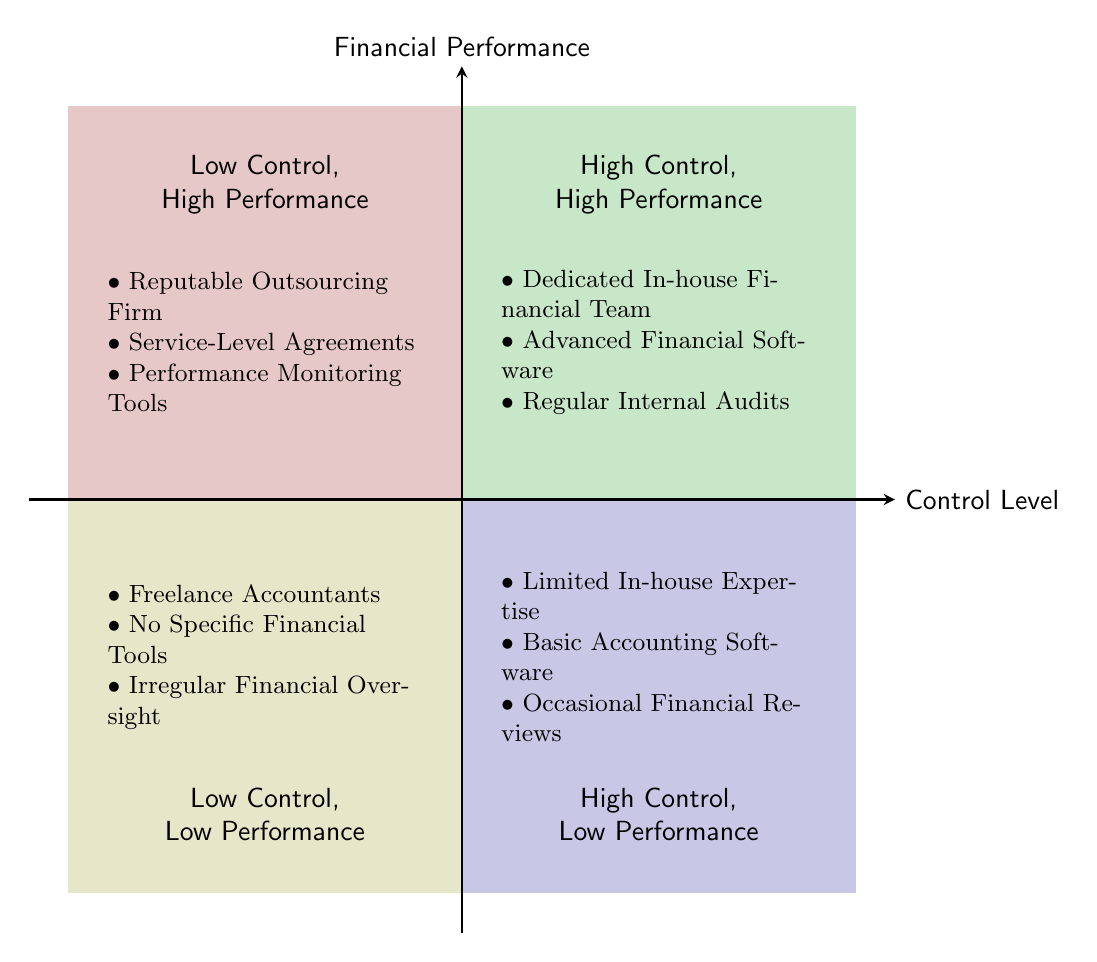What are the elements in the top right quadrant? In the top right quadrant labeled "High Control, High Performance," the elements listed are: Dedicated In-house Financial Team, Advanced Financial Software (e.g. QuickBooks, Xero), and Regular Internal Audits.
Answer: Dedicated In-house Financial Team, Advanced Financial Software, Regular Internal Audits How many quadrants are there in the diagram? The diagram is divided into four distinct quadrants, illustrating different combinations of control levels and financial performance.
Answer: Four Which quadrant features reputable outsourcing firms? The quadrant that features reputable outsourcing firms is the top left quadrant, also known as "Low Control, High Performance."
Answer: Low Control, High Performance What is the relationship between high control and financial performance in the bottom right quadrant? In the bottom right quadrant, labeled "High Control, Low Performance," it indicates that despite having high control, the performance remains low. This highlights a disconnect where control doesn't guarantee financial success.
Answer: High Control, Low Performance Which financial management option has no specific financial tools? The option with no specific financial tools is located in the bottom left quadrant, categorized as "Low Control, Low Performance," which includes Freelance Accountants and Irregular Financial Oversight.
Answer: Freelance Accountants What combination of control level and performance is associated with limited in-house expertise? The combination of high control and low performance is related to limited in-house expertise, as seen in the bottom right quadrant.
Answer: High Control, Low Performance How is performance monitored in the top left quadrant? In the top left quadrant, performance is monitored through Service-Level Agreements (SLAs) and Performance Monitoring Tools, ensuring that financial services meet agreed standards.
Answer: Service-Level Agreements, Performance Monitoring Tools What is characteristic of the services listed in the bottom left quadrant? The bottom left quadrant represents financial management options that depict both low control and low performance, showcasing irregular financial oversight and reliance on freelance accountants.
Answer: Low Control, Low Performance 